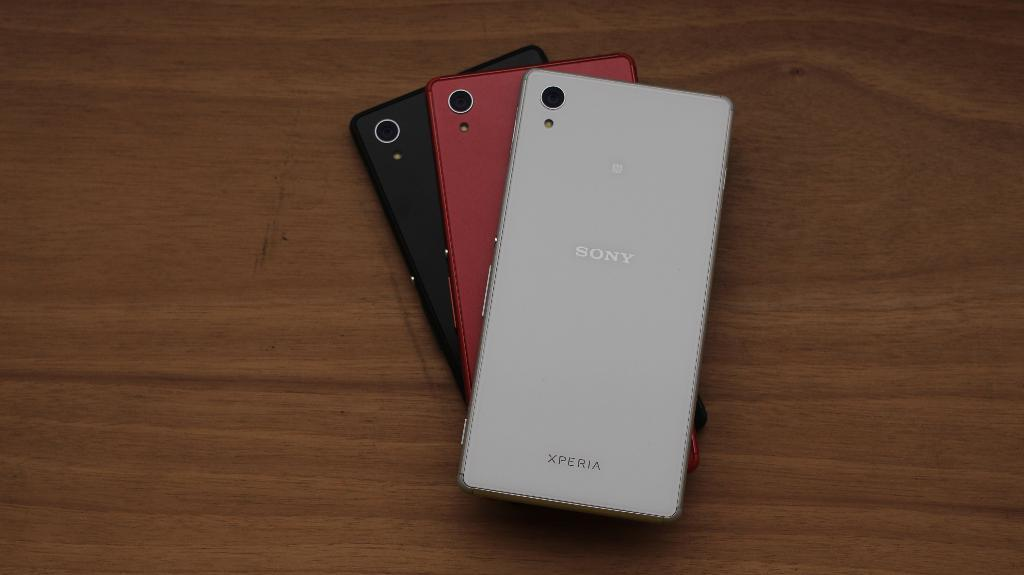<image>
Write a terse but informative summary of the picture. Three Sony mobile phones, one red one black one white,  sit one on top the other but fanned out so the reverse of all three is visible. 